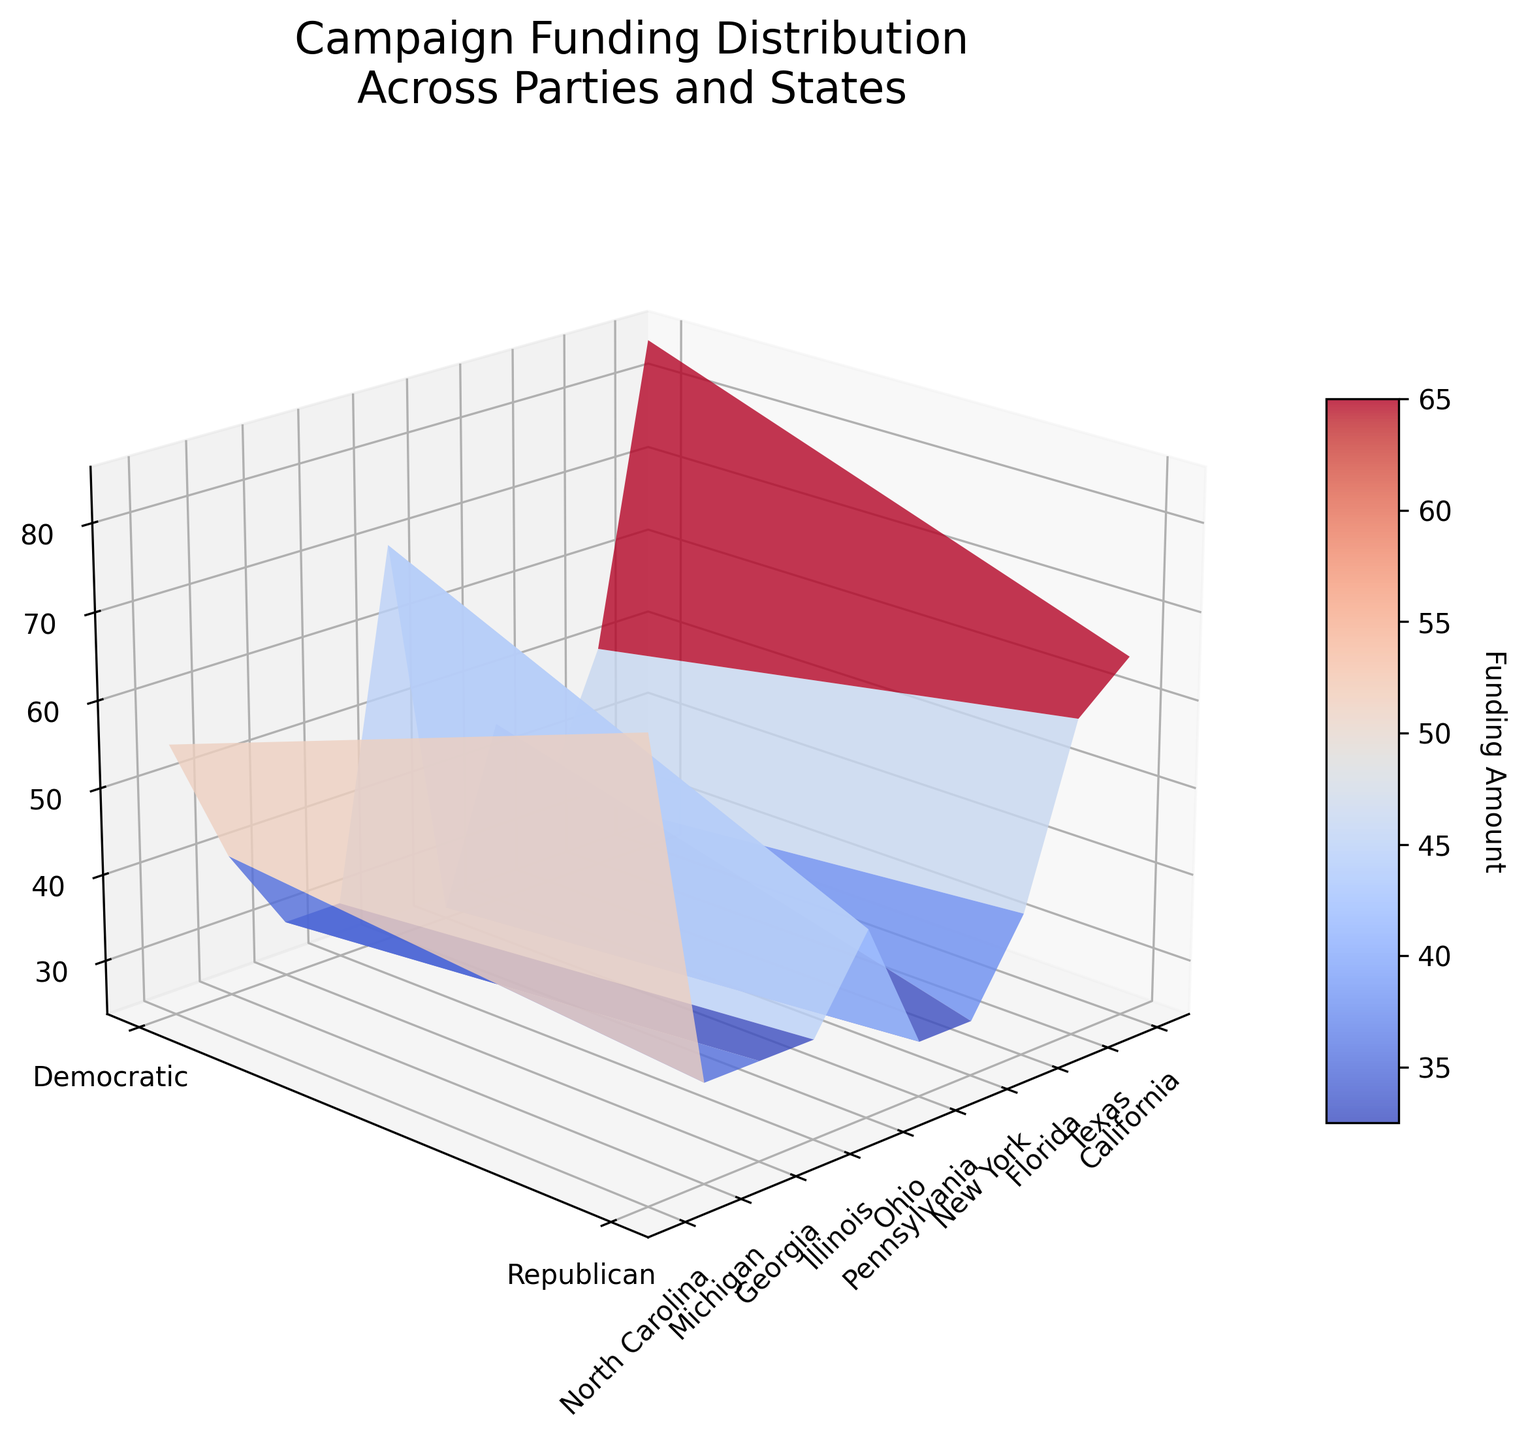What's the color scheme used in the plot? The plot uses a 'coolwarm' colormap, where colors range from cool (blue) to warm (red).
Answer: coolwarm What is the title of the plot? The title is displayed at the top of the figure and reads "Campaign Funding Distribution Across Parties and States".
Answer: Campaign Funding Distribution Across Parties and States Which state received the highest Democratic funding? By examining the Z-values for the 'Democratic' row, the peak is for California with a funding of 85 million.
Answer: California Compare the funding of Republican and Democratic parties in Texas. Which is higher? The 'Funding (Millions)' value for Republican in Texas is 75 million, while for Democratic it is 55 million. Therefore, Republican funding is higher in Texas.
Answer: Republican What is the average funding received by the Democratic party across all states? To find the average, sum the funding amounts (85+55+50+70+40+30+45+35+25+30 = 465) and divide by the number of states (10). The average is 465/10 = 46.5.
Answer: 46.5 Which party received more funding in Florida, and by how much? The Democratic party received 50 million while the Republican party received 60 million in Florida, so the Republicans received 10 million more.
Answer: Republican, 10 million Is there any state where both parties received equal funding? Upon inspection of the Z-values in the matrix, Ohio is the only state where funding for both parties is equal at 35 million.
Answer: Ohio What's the difference between the highest and lowest funding amounts for the Democratic party? The highest funding amount is in California (85 million) and the lowest is in Michigan (25 million), so the difference is 85 - 25 = 60.
Answer: 60 In how many states does the Republican party receive more funding than the Democratic party? By comparing the values for each state, Republicans receive more funding than Democrats in Texas, Florida, Georgia, Michigan, and North Carolina. That's 5 states.
Answer: 5 